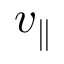<formula> <loc_0><loc_0><loc_500><loc_500>v _ { \| }</formula> 